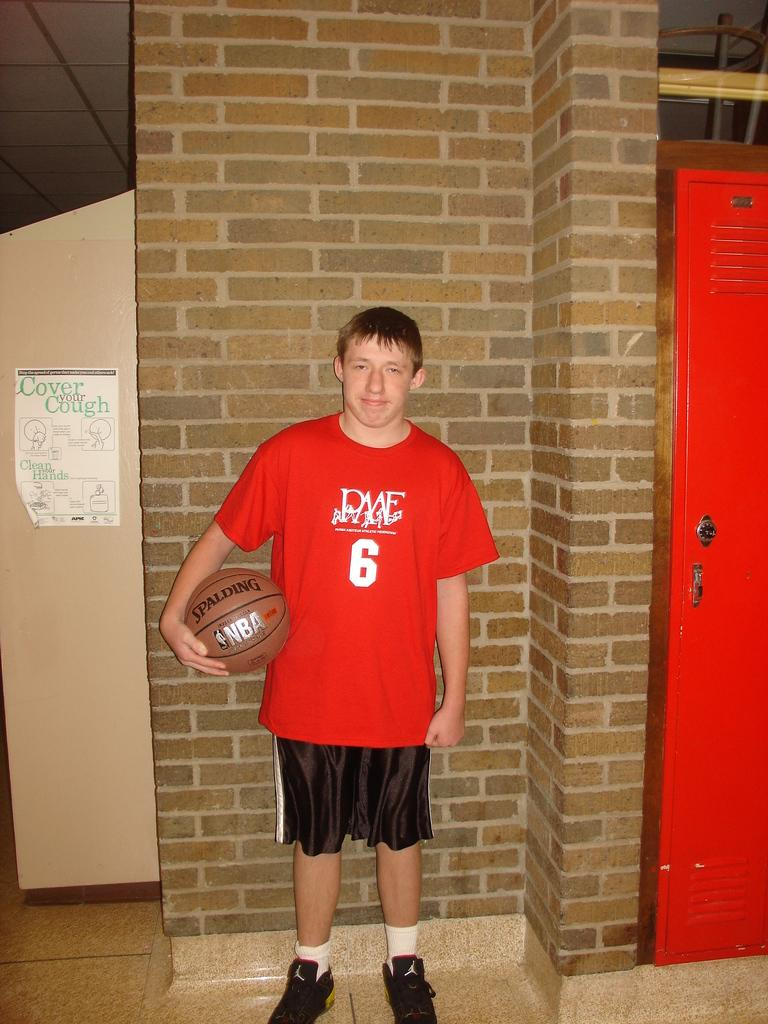<image>
Write a terse but informative summary of the picture. The young basketball player for the PME team stands posing with his Spalding basketball. 